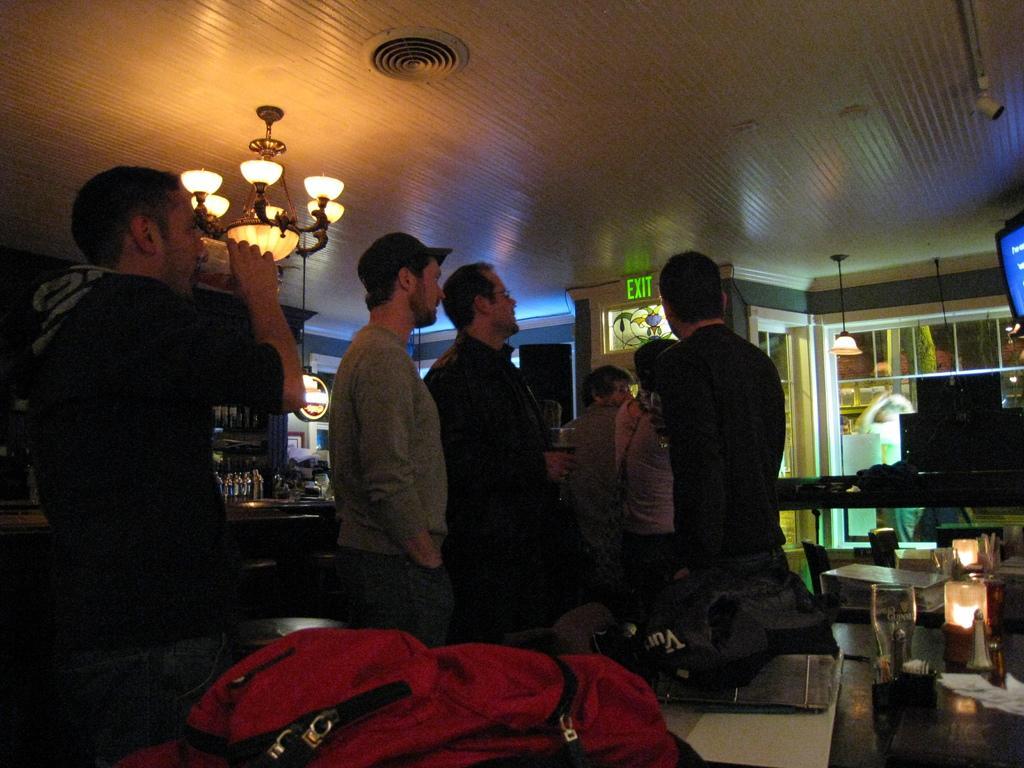How would you summarize this image in a sentence or two? Here in this picture we can see a group of people standing over a place and the person on the left side is drinking something present in the glass in his hand and on the roof we can see a chandelier present and in the front we can see a table, on which we can see glasses and bags present all over there and beside them we can see bottles of alcohol here and there and on the right side we can see television present on the wall over there. 